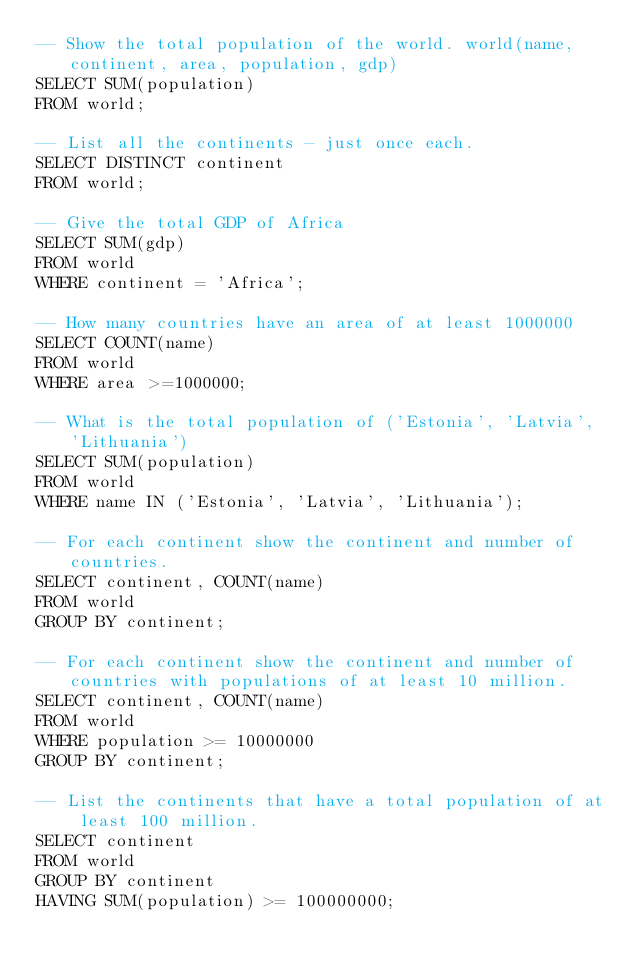<code> <loc_0><loc_0><loc_500><loc_500><_SQL_>-- Show the total population of the world. world(name, continent, area, population, gdp)
SELECT SUM(population)
FROM world;

-- List all the continents - just once each.
SELECT DISTINCT continent
FROM world;

-- Give the total GDP of Africa
SELECT SUM(gdp)
FROM world
WHERE continent = 'Africa';

-- How many countries have an area of at least 1000000
SELECT COUNT(name)
FROM world
WHERE area >=1000000;

-- What is the total population of ('Estonia', 'Latvia', 'Lithuania')
SELECT SUM(population)
FROM world
WHERE name IN ('Estonia', 'Latvia', 'Lithuania');

-- For each continent show the continent and number of countries.
SELECT continent, COUNT(name)
FROM world
GROUP BY continent;

-- For each continent show the continent and number of countries with populations of at least 10 million.
SELECT continent, COUNT(name)
FROM world
WHERE population >= 10000000
GROUP BY continent;

-- List the continents that have a total population of at least 100 million.
SELECT continent
FROM world
GROUP BY continent
HAVING SUM(population) >= 100000000;
</code> 